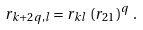Convert formula to latex. <formula><loc_0><loc_0><loc_500><loc_500>r _ { k + 2 q , l } = r _ { k l } \, \left ( r _ { 2 1 } \right ) ^ { q } \, .</formula> 